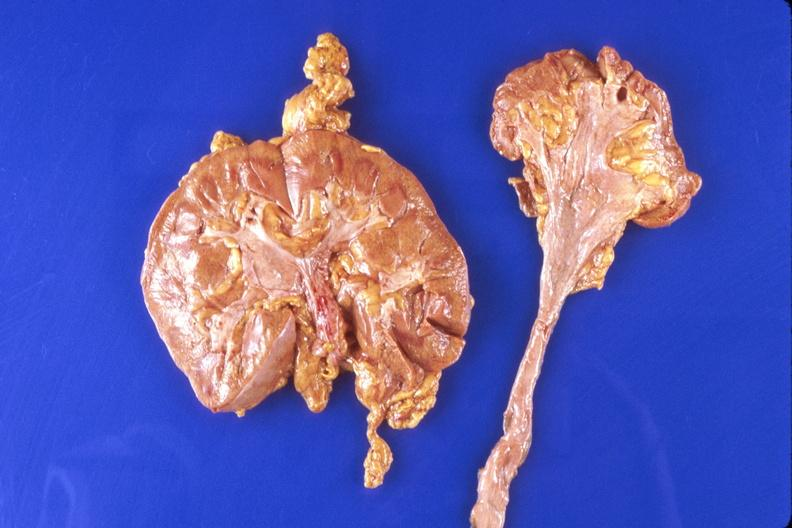does this image show kidney, hypoplasia and compensatory hypertrophy of contralateral kidney?
Answer the question using a single word or phrase. Yes 